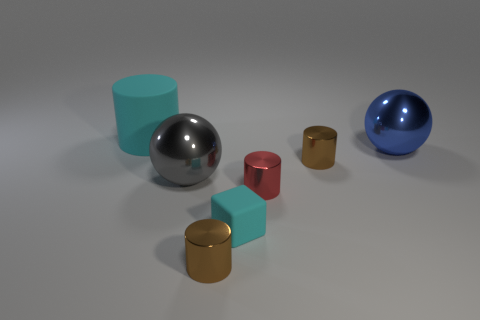Subtract 1 cylinders. How many cylinders are left? 3 Add 1 brown cylinders. How many objects exist? 8 Subtract all balls. How many objects are left? 5 Subtract all cylinders. Subtract all gray metal balls. How many objects are left? 2 Add 4 big gray shiny objects. How many big gray shiny objects are left? 5 Add 7 brown cylinders. How many brown cylinders exist? 9 Subtract 1 cyan cubes. How many objects are left? 6 